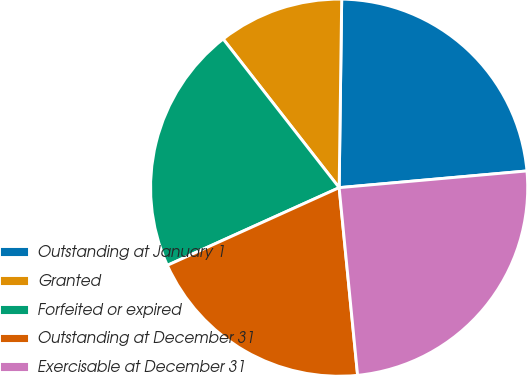Convert chart to OTSL. <chart><loc_0><loc_0><loc_500><loc_500><pie_chart><fcel>Outstanding at January 1<fcel>Granted<fcel>Forfeited or expired<fcel>Outstanding at December 31<fcel>Exercisable at December 31<nl><fcel>23.37%<fcel>10.76%<fcel>21.21%<fcel>19.8%<fcel>24.85%<nl></chart> 